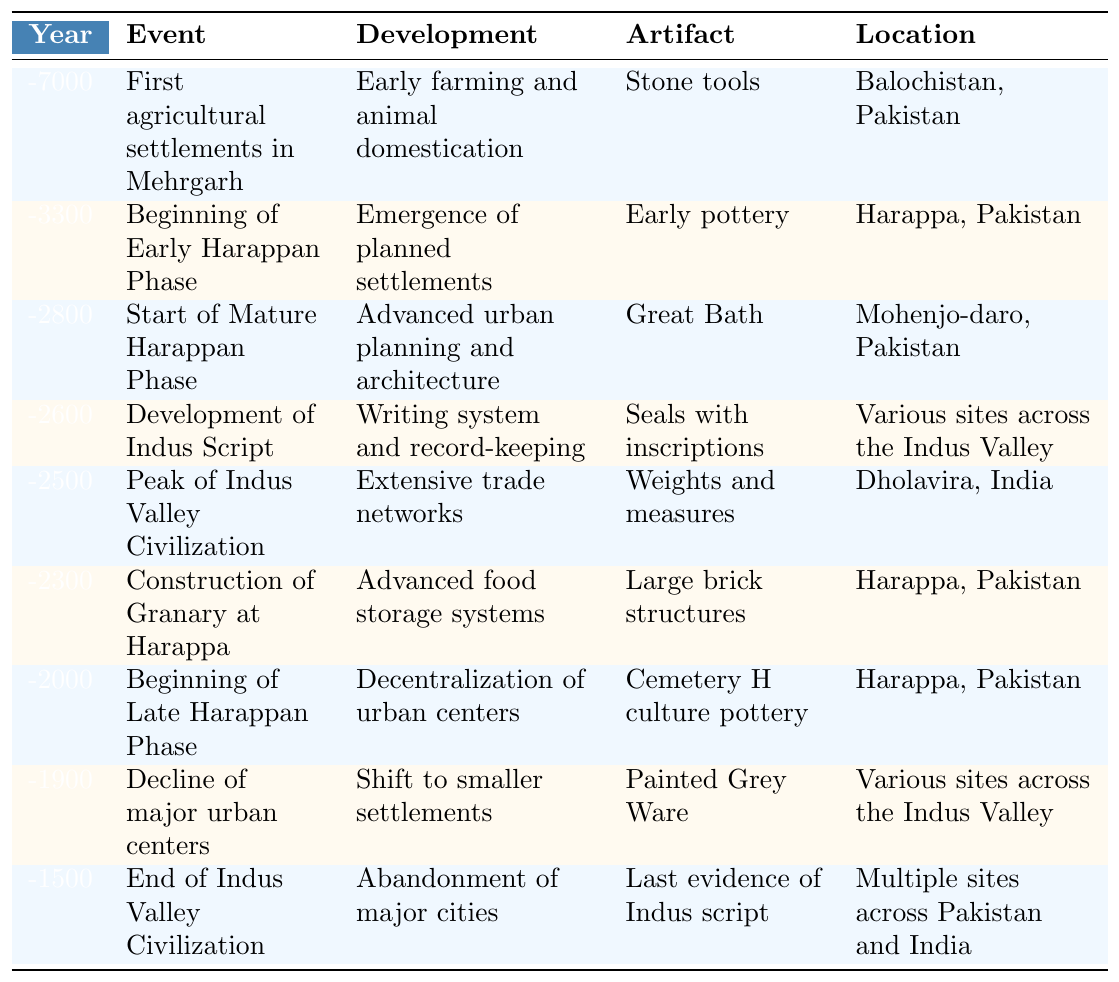What year did the Indus Valley Civilization reach its peak? By looking at the table, we find the event "Peak of Indus Valley Civilization" listed under the year -2500.
Answer: -2500 Which artifact is associated with the construction of the Granary at Harappa? In the entry for the year -2300, the artifact associated with the construction of the Granary at Harappa is mentioned as "Large brick structures."
Answer: Large brick structures What was the development associated with the beginning of the Late Harappan Phase? Referring to the entry for -2000, the development during this phase is "Decentralization of urban centers."
Answer: Decentralization of urban centers What is the earliest recorded event in the timeline? The first entry in the table for the year -7000 indicates the first agricultural settlements in Mehrgarh.
Answer: First agricultural settlements in Mehrgarh How many years are there between the beginning of the Early Harappan Phase and the end of the Indus Valley Civilization? The beginning of the Early Harappan Phase is in -3300, and the end is in -1500. The difference is
Answer: 1800 years True or False: The Great Bath was built during the Late Harappan Phase. The Great Bath is associated with the Mature Harappan Phase, which starts in -2800, while the Late Harappan Phase begins in -2000. Therefore, this statement is false.
Answer: False Which location has the earliest agricultural settlements? The entry for -7000 shows that the first agricultural settlements were in Balochistan, Pakistan.
Answer: Balochistan, Pakistan During which year was the Indus Script developed? According to the table, the Indus Script was developed in the year -2600.
Answer: -2600 What development is associated with the year -1900? In the row for -1900, it states that the development was a "Shift to smaller settlements."
Answer: Shift to smaller settlements Is there evidence of trade networks at the peak of the civilization? The entry for -2500 mentions "Extensive trade networks" as a development during the peak of the Indus Valley Civilization, confirming the existence of such evidence.
Answer: Yes 